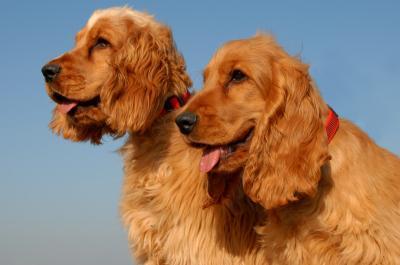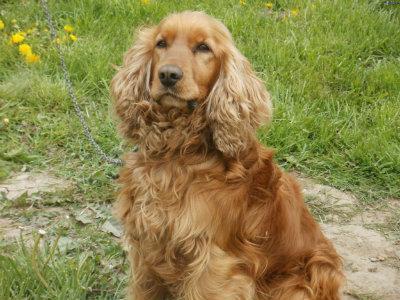The first image is the image on the left, the second image is the image on the right. For the images displayed, is the sentence "At least three dogs, all of them the same breed, but different colors, are in one image." factually correct? Answer yes or no. No. The first image is the image on the left, the second image is the image on the right. Considering the images on both sides, is "There are no fewer than two dogs out doors in the image on the left." valid? Answer yes or no. Yes. 